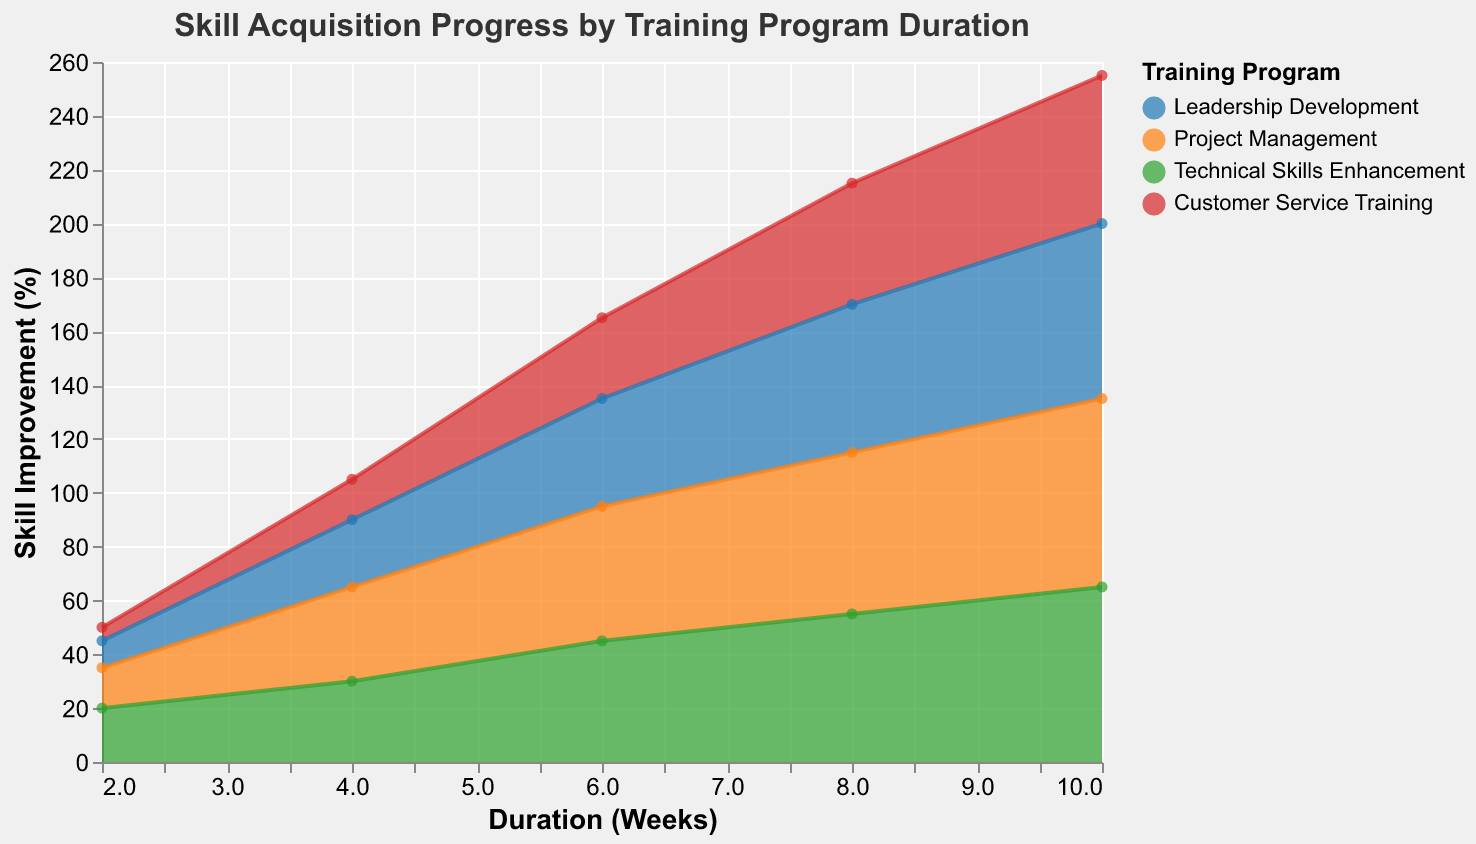What is the title of the chart? The title of the chart is displayed at the top, reading "Skill Acquisition Progress by Training Program Duration".
Answer: Skill Acquisition Progress by Training Program Duration What is the color used for the "Leadership Development" training program line? The color legend on the right of the chart shows that the "Leadership Development" line is blue.
Answer: Blue What is the skill improvement percentage for "Customer Service Training" after 4 weeks? On the x-axis, find the point where Duration_Weeks is 4 for the Customer Service Training line. The y-axis value at this point is 15.
Answer: 15% How many training programs are compared in this chart? The legend indicates there are four training programs: "Leadership Development," "Project Management," "Technical Skills Enhancement," and "Customer Service Training".
Answer: 4 Which training program shows the highest skill improvement at the end of 10 weeks? By looking at the y-axis values for Duration_Weeks = 10 for all lines, "Project Management" reaches 70%, which is the highest among all programs.
Answer: Project Management What is the overall trend of skill improvement for the "Technical Skills Enhancement" program? For the "Technical Skills Enhancement" program, observe the points at each duration increment (2, 4, 6, 8, 10 weeks). The skill improvement starts at 20% and progressively increases to 65%.
Answer: Increasing How does the skill improvement of "Leadership Development" compare to "Project Management" after 6 weeks? At the Duration_Weeks = 6 mark, "Leadership Development" shows 40% improvement and "Project Management" shows 50%. "Project Management" has a higher skill improvement at this point.
Answer: Project Management is higher What is the average skill improvement for "Customer Service Training" across all measured durations? Add up the skill improvement percentages at 2, 4, 6, 8, and 10 weeks (5% + 15% + 30% + 45% + 55% = 150%) and divide by the number of durations (5).
Answer: 30% Between which weeks does "Leadership Development" see the greatest increase in skill improvement? By comparing the increments, the greatest increase for "Leadership Development" is between weeks 2 to 4 (15% increase), from 10% to 25%.
Answer: Between 2 and 4 weeks Does any training program reach a skill improvement percentage of 80% or higher? Check the highest skill improvement percentage on the y-axis for all programs. None of the lines reach or exceed 80%.
Answer: No 